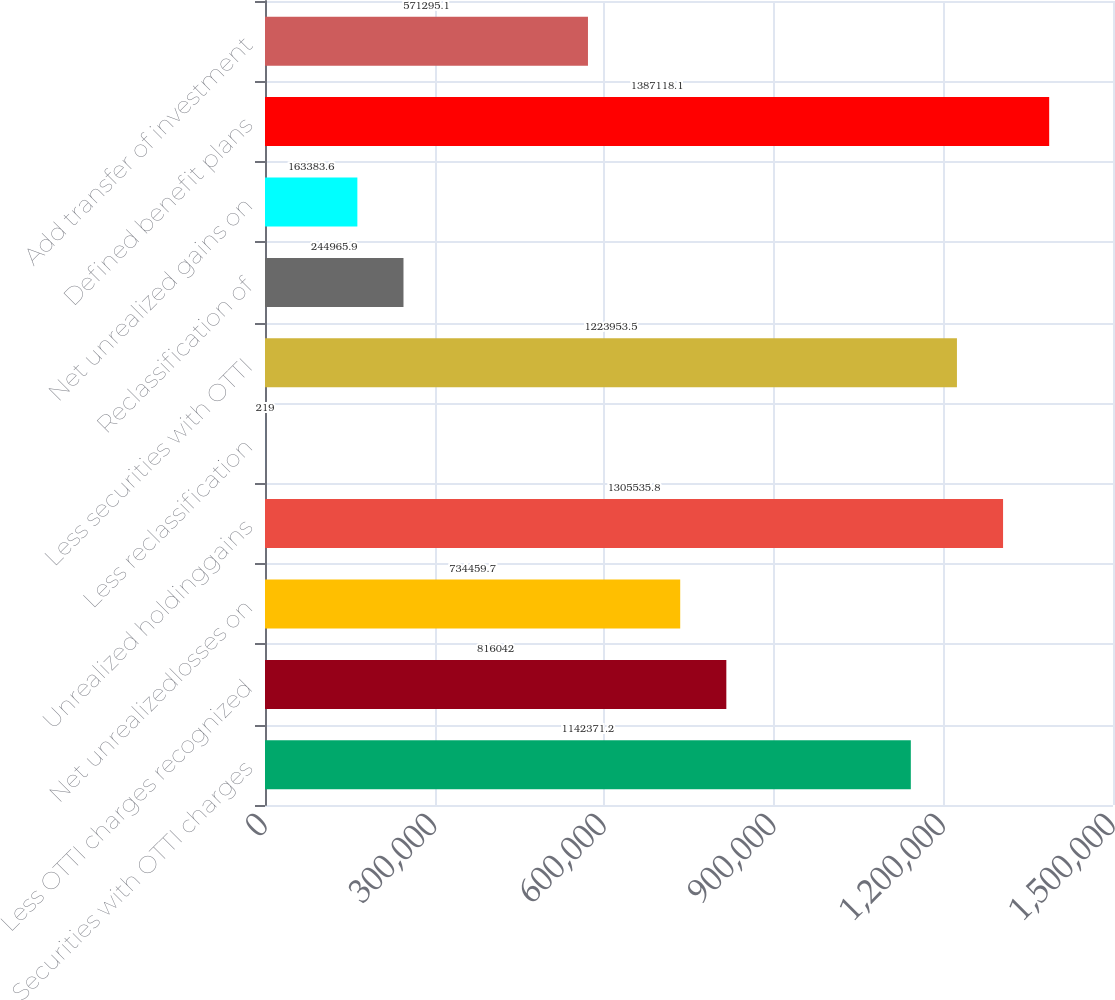<chart> <loc_0><loc_0><loc_500><loc_500><bar_chart><fcel>Securities with OTTI charges<fcel>Less OTTI charges recognized<fcel>Net unrealizedlosses on<fcel>Unrealized holdinggains<fcel>Less reclassification<fcel>Less securities with OTTI<fcel>Reclassification of<fcel>Net unrealized gains on<fcel>Defined benefit plans<fcel>Add transfer of investment<nl><fcel>1.14237e+06<fcel>816042<fcel>734460<fcel>1.30554e+06<fcel>219<fcel>1.22395e+06<fcel>244966<fcel>163384<fcel>1.38712e+06<fcel>571295<nl></chart> 